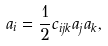<formula> <loc_0><loc_0><loc_500><loc_500>a _ { i } = \frac { 1 } { 2 } c _ { i j k } a _ { j } a _ { k } ,</formula> 